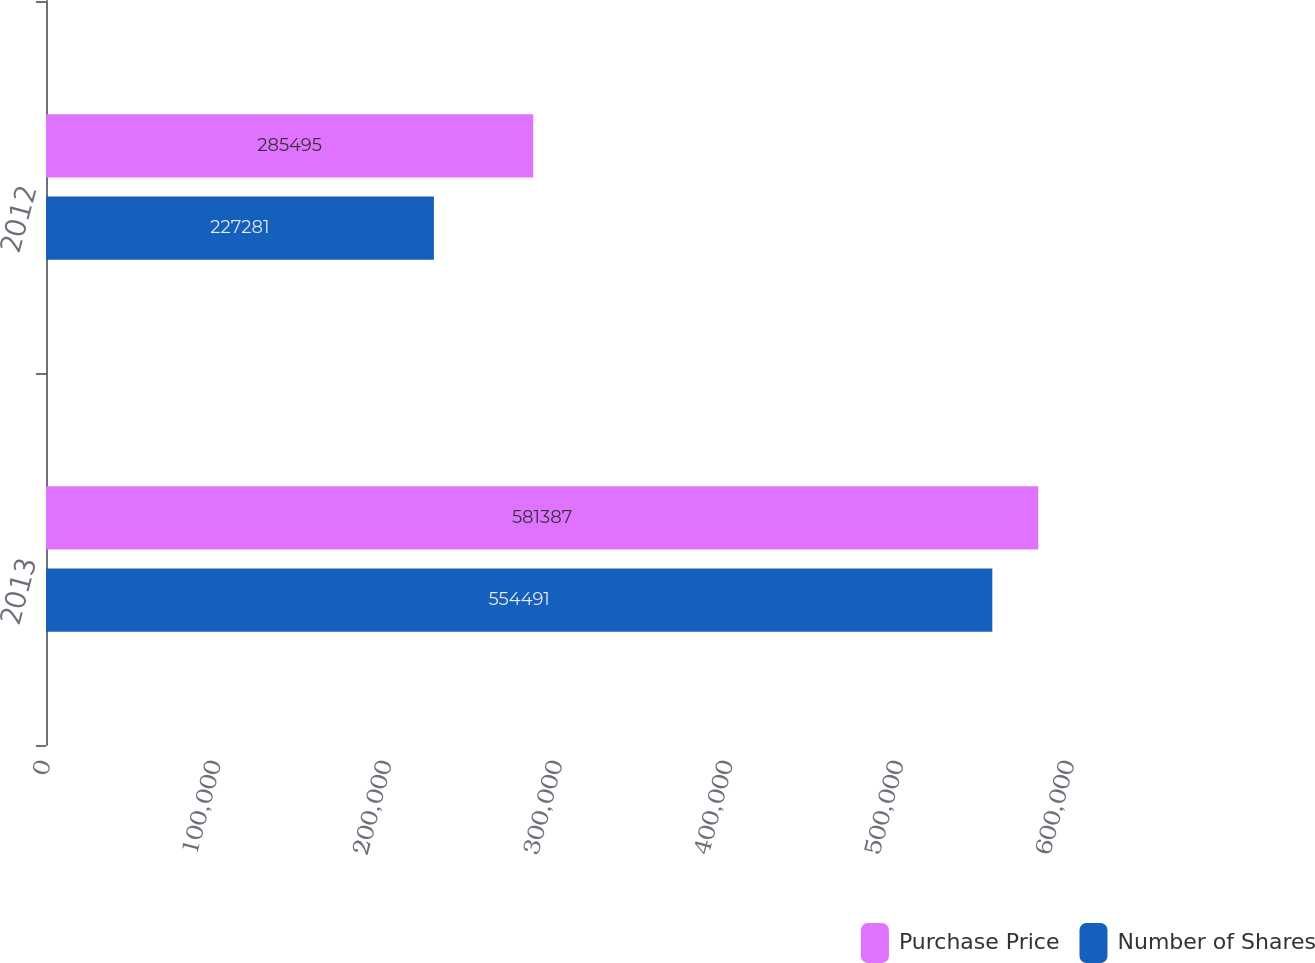Convert chart to OTSL. <chart><loc_0><loc_0><loc_500><loc_500><stacked_bar_chart><ecel><fcel>2013<fcel>2012<nl><fcel>Purchase Price<fcel>581387<fcel>285495<nl><fcel>Number of Shares<fcel>554491<fcel>227281<nl></chart> 